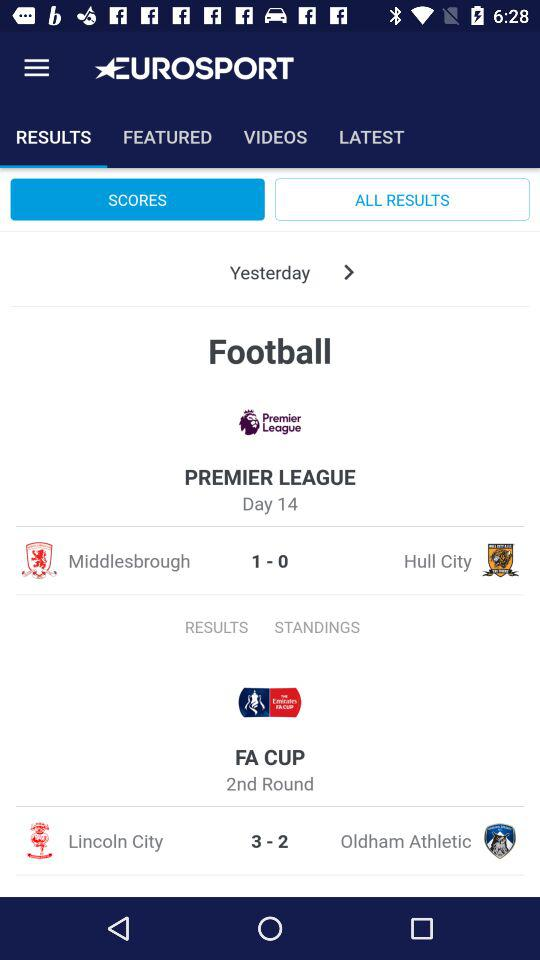Which team has the higher score in the Premier League, Middlesbrough or Hull City?
Answer the question using a single word or phrase. Middlesbrough 